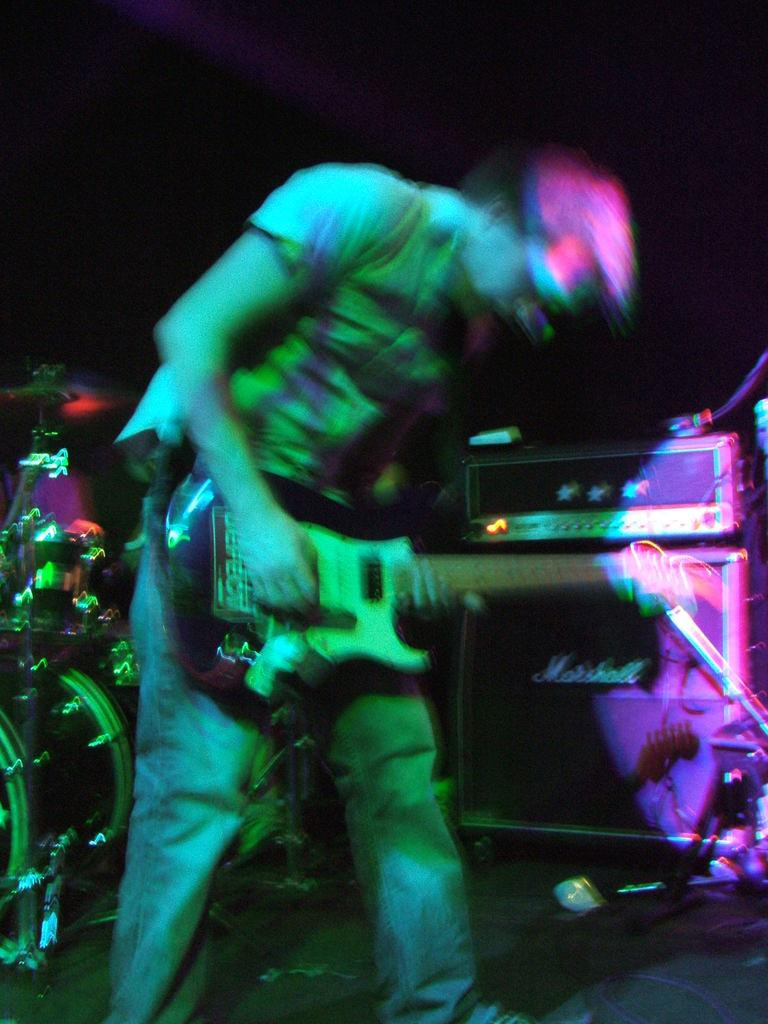What is the man in the image doing? The man is playing a guitar. What other musical instruments can be seen in the image? There are other musical instruments in the background of the image. What sign is the man holding while playing the guitar in the image? There is no sign present in the image; the man is simply playing the guitar. 